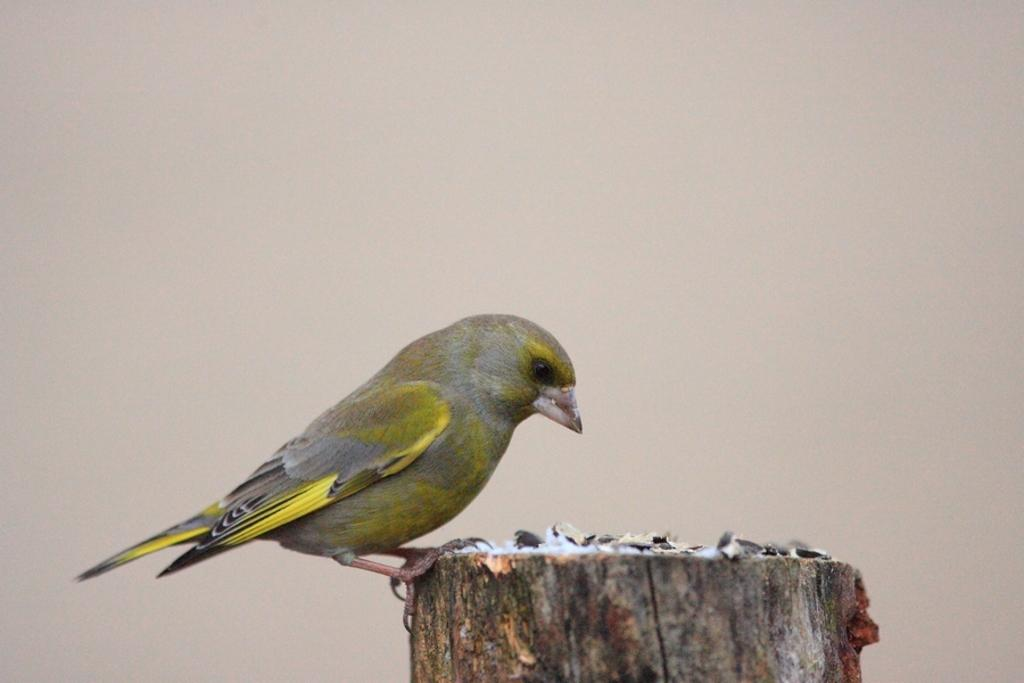What type of animal is in the image? There is a bird in the image. Where is the bird located? The bird is on a wooden surface. What color is the background of the image? The background of the image is cream-colored. What type of bomb is visible in the image? There is no bomb present in the image; it features a bird on a wooden surface with a cream-colored background. 